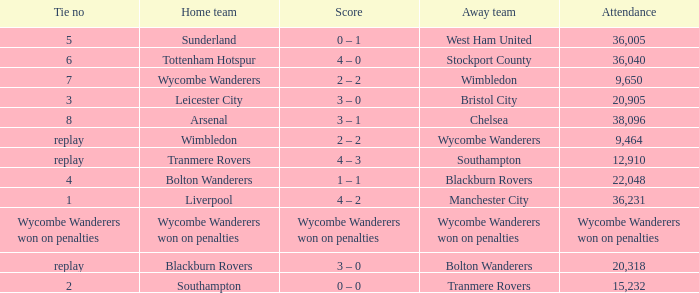What was the name of the away team that had a tie of 2? Tranmere Rovers. 